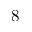<formula> <loc_0><loc_0><loc_500><loc_500>8</formula> 